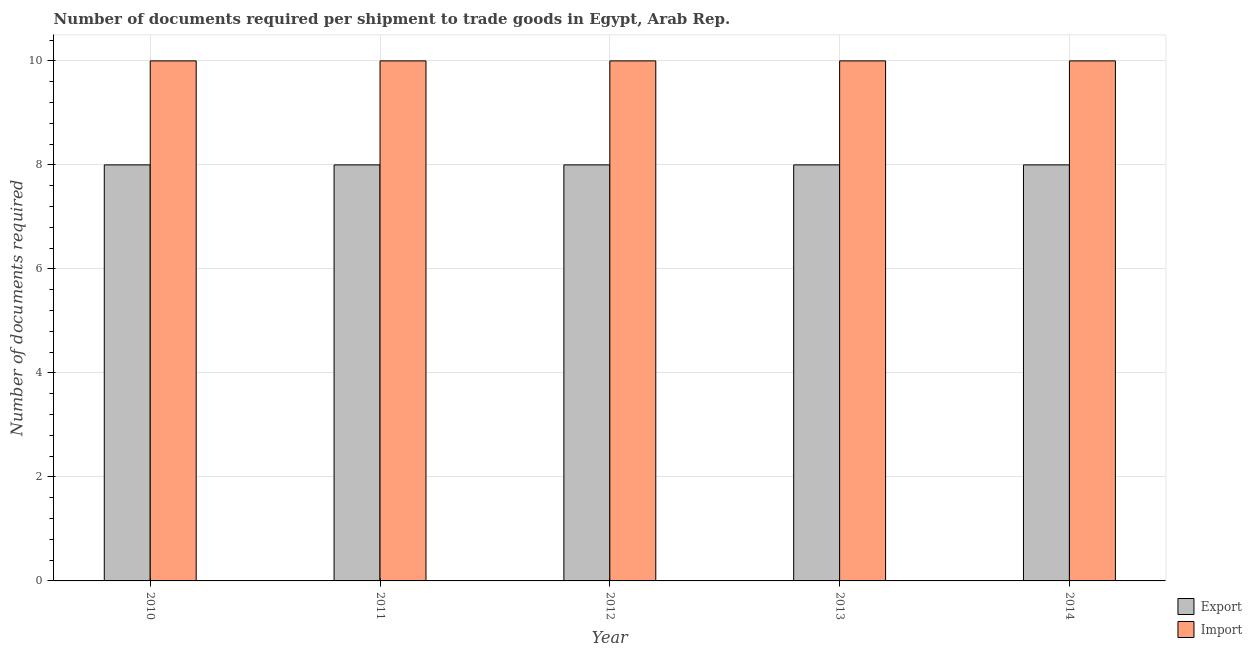Are the number of bars on each tick of the X-axis equal?
Your response must be concise. Yes. What is the number of documents required to import goods in 2014?
Give a very brief answer. 10. Across all years, what is the maximum number of documents required to export goods?
Your answer should be very brief. 8. Across all years, what is the minimum number of documents required to import goods?
Offer a very short reply. 10. In which year was the number of documents required to export goods minimum?
Provide a succinct answer. 2010. What is the total number of documents required to export goods in the graph?
Provide a short and direct response. 40. What is the difference between the number of documents required to import goods in 2011 and the number of documents required to export goods in 2010?
Your answer should be compact. 0. In how many years, is the number of documents required to import goods greater than 6.8?
Your response must be concise. 5. In how many years, is the number of documents required to import goods greater than the average number of documents required to import goods taken over all years?
Provide a succinct answer. 0. What does the 2nd bar from the left in 2010 represents?
Make the answer very short. Import. What does the 2nd bar from the right in 2012 represents?
Make the answer very short. Export. How many legend labels are there?
Provide a succinct answer. 2. What is the title of the graph?
Your response must be concise. Number of documents required per shipment to trade goods in Egypt, Arab Rep. What is the label or title of the X-axis?
Offer a terse response. Year. What is the label or title of the Y-axis?
Offer a very short reply. Number of documents required. What is the Number of documents required of Import in 2010?
Offer a very short reply. 10. What is the Number of documents required of Export in 2012?
Provide a succinct answer. 8. What is the Number of documents required of Import in 2012?
Offer a terse response. 10. What is the Number of documents required of Export in 2014?
Offer a very short reply. 8. Across all years, what is the minimum Number of documents required of Export?
Give a very brief answer. 8. What is the difference between the Number of documents required of Export in 2010 and that in 2012?
Provide a short and direct response. 0. What is the difference between the Number of documents required of Export in 2010 and that in 2013?
Ensure brevity in your answer.  0. What is the difference between the Number of documents required in Export in 2010 and that in 2014?
Your answer should be compact. 0. What is the difference between the Number of documents required of Import in 2011 and that in 2012?
Offer a terse response. 0. What is the difference between the Number of documents required of Export in 2011 and that in 2013?
Offer a terse response. 0. What is the difference between the Number of documents required of Import in 2011 and that in 2013?
Give a very brief answer. 0. What is the difference between the Number of documents required of Export in 2011 and that in 2014?
Offer a terse response. 0. What is the difference between the Number of documents required in Import in 2011 and that in 2014?
Make the answer very short. 0. What is the difference between the Number of documents required of Export in 2012 and that in 2013?
Provide a short and direct response. 0. What is the difference between the Number of documents required in Import in 2012 and that in 2013?
Your response must be concise. 0. What is the difference between the Number of documents required in Export in 2012 and that in 2014?
Keep it short and to the point. 0. What is the difference between the Number of documents required in Import in 2012 and that in 2014?
Ensure brevity in your answer.  0. What is the difference between the Number of documents required of Import in 2013 and that in 2014?
Offer a very short reply. 0. What is the difference between the Number of documents required in Export in 2010 and the Number of documents required in Import in 2014?
Offer a terse response. -2. What is the difference between the Number of documents required of Export in 2011 and the Number of documents required of Import in 2014?
Your answer should be very brief. -2. What is the difference between the Number of documents required in Export in 2012 and the Number of documents required in Import in 2013?
Your answer should be very brief. -2. What is the difference between the Number of documents required of Export in 2013 and the Number of documents required of Import in 2014?
Ensure brevity in your answer.  -2. What is the average Number of documents required of Export per year?
Make the answer very short. 8. What is the average Number of documents required in Import per year?
Your answer should be compact. 10. In the year 2010, what is the difference between the Number of documents required of Export and Number of documents required of Import?
Make the answer very short. -2. In the year 2012, what is the difference between the Number of documents required in Export and Number of documents required in Import?
Keep it short and to the point. -2. In the year 2014, what is the difference between the Number of documents required in Export and Number of documents required in Import?
Keep it short and to the point. -2. What is the ratio of the Number of documents required in Import in 2010 to that in 2012?
Provide a short and direct response. 1. What is the ratio of the Number of documents required in Export in 2010 to that in 2013?
Provide a short and direct response. 1. What is the ratio of the Number of documents required in Export in 2010 to that in 2014?
Your response must be concise. 1. What is the ratio of the Number of documents required of Import in 2010 to that in 2014?
Keep it short and to the point. 1. What is the ratio of the Number of documents required of Export in 2011 to that in 2012?
Provide a succinct answer. 1. What is the ratio of the Number of documents required of Import in 2011 to that in 2014?
Provide a short and direct response. 1. What is the ratio of the Number of documents required in Import in 2012 to that in 2013?
Your answer should be compact. 1. What is the ratio of the Number of documents required in Export in 2013 to that in 2014?
Provide a short and direct response. 1. What is the difference between the highest and the second highest Number of documents required of Export?
Your answer should be compact. 0. What is the difference between the highest and the lowest Number of documents required in Import?
Make the answer very short. 0. 